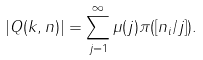Convert formula to latex. <formula><loc_0><loc_0><loc_500><loc_500>| Q ( k , n ) | = \sum _ { j = 1 } ^ { \infty } \mu ( j ) \pi ( [ n _ { i } / j ] ) .</formula> 